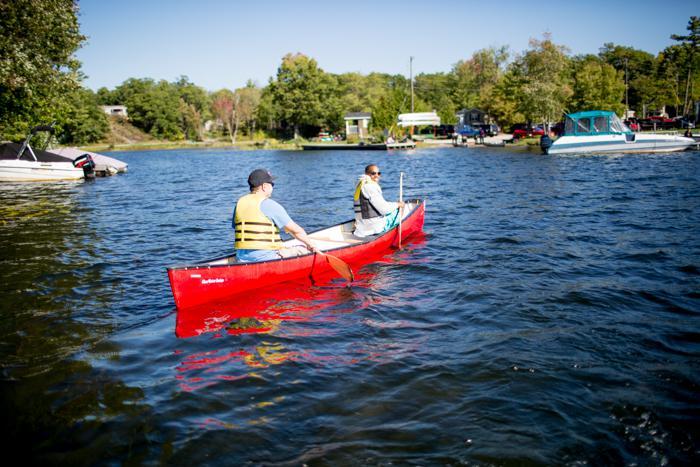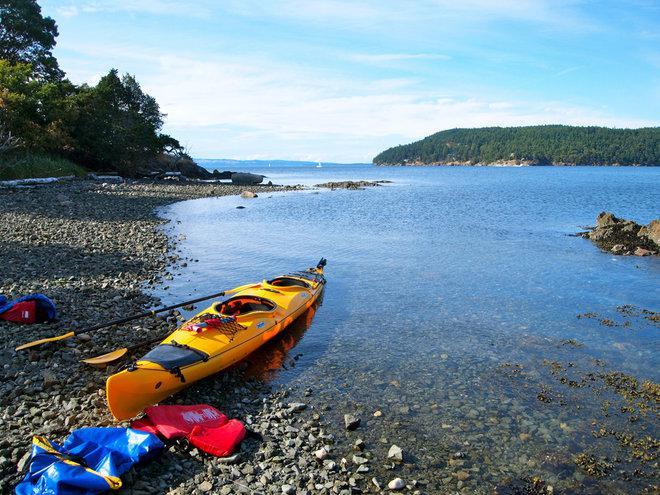The first image is the image on the left, the second image is the image on the right. For the images shown, is this caption "There are two vessels in the water in one of the images." true? Answer yes or no. No. The first image is the image on the left, the second image is the image on the right. Assess this claim about the two images: "An image shows one boat with at least four aboard going to the right.". Correct or not? Answer yes or no. No. 